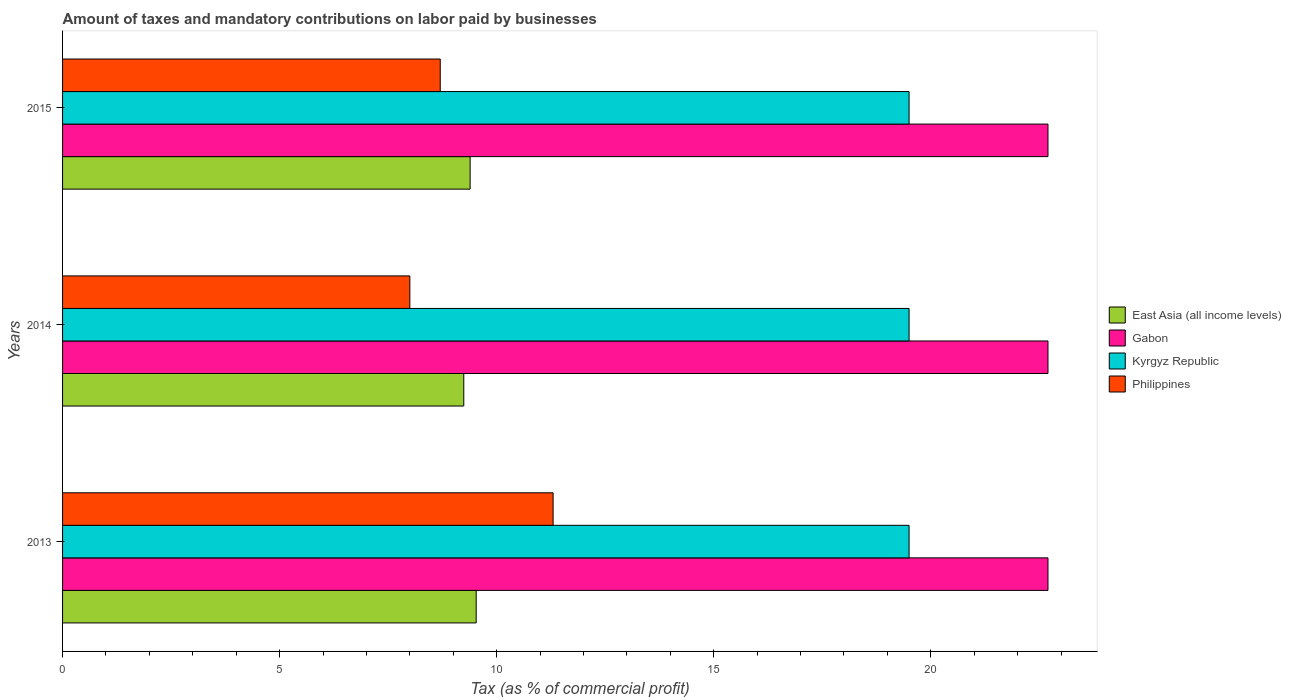How many different coloured bars are there?
Provide a short and direct response. 4. Are the number of bars per tick equal to the number of legend labels?
Ensure brevity in your answer.  Yes. Are the number of bars on each tick of the Y-axis equal?
Offer a terse response. Yes. How many bars are there on the 2nd tick from the top?
Your answer should be compact. 4. How many bars are there on the 2nd tick from the bottom?
Give a very brief answer. 4. What is the label of the 1st group of bars from the top?
Ensure brevity in your answer.  2015. What is the percentage of taxes paid by businesses in Gabon in 2015?
Keep it short and to the point. 22.7. Across all years, what is the minimum percentage of taxes paid by businesses in East Asia (all income levels)?
Ensure brevity in your answer.  9.24. In which year was the percentage of taxes paid by businesses in Philippines minimum?
Your answer should be very brief. 2014. What is the total percentage of taxes paid by businesses in Gabon in the graph?
Your answer should be very brief. 68.1. What is the difference between the percentage of taxes paid by businesses in Gabon in 2014 and that in 2015?
Provide a succinct answer. 0. What is the difference between the percentage of taxes paid by businesses in Philippines in 2014 and the percentage of taxes paid by businesses in Kyrgyz Republic in 2013?
Provide a short and direct response. -11.5. What is the average percentage of taxes paid by businesses in East Asia (all income levels) per year?
Provide a short and direct response. 9.39. In the year 2013, what is the difference between the percentage of taxes paid by businesses in Gabon and percentage of taxes paid by businesses in Kyrgyz Republic?
Provide a short and direct response. 3.2. What is the ratio of the percentage of taxes paid by businesses in Gabon in 2013 to that in 2014?
Offer a very short reply. 1. Is the percentage of taxes paid by businesses in Gabon in 2013 less than that in 2014?
Keep it short and to the point. No. Is the difference between the percentage of taxes paid by businesses in Gabon in 2013 and 2014 greater than the difference between the percentage of taxes paid by businesses in Kyrgyz Republic in 2013 and 2014?
Keep it short and to the point. No. What is the difference between the highest and the second highest percentage of taxes paid by businesses in Philippines?
Provide a succinct answer. 2.6. What is the difference between the highest and the lowest percentage of taxes paid by businesses in Philippines?
Offer a terse response. 3.3. Is the sum of the percentage of taxes paid by businesses in East Asia (all income levels) in 2013 and 2014 greater than the maximum percentage of taxes paid by businesses in Gabon across all years?
Offer a very short reply. No. Is it the case that in every year, the sum of the percentage of taxes paid by businesses in Kyrgyz Republic and percentage of taxes paid by businesses in Gabon is greater than the sum of percentage of taxes paid by businesses in Philippines and percentage of taxes paid by businesses in East Asia (all income levels)?
Your response must be concise. Yes. What does the 2nd bar from the bottom in 2013 represents?
Make the answer very short. Gabon. Is it the case that in every year, the sum of the percentage of taxes paid by businesses in East Asia (all income levels) and percentage of taxes paid by businesses in Philippines is greater than the percentage of taxes paid by businesses in Kyrgyz Republic?
Provide a short and direct response. No. How many years are there in the graph?
Keep it short and to the point. 3. Are the values on the major ticks of X-axis written in scientific E-notation?
Offer a very short reply. No. How many legend labels are there?
Provide a short and direct response. 4. What is the title of the graph?
Provide a short and direct response. Amount of taxes and mandatory contributions on labor paid by businesses. What is the label or title of the X-axis?
Offer a very short reply. Tax (as % of commercial profit). What is the label or title of the Y-axis?
Give a very brief answer. Years. What is the Tax (as % of commercial profit) in East Asia (all income levels) in 2013?
Ensure brevity in your answer.  9.53. What is the Tax (as % of commercial profit) of Gabon in 2013?
Your response must be concise. 22.7. What is the Tax (as % of commercial profit) in East Asia (all income levels) in 2014?
Ensure brevity in your answer.  9.24. What is the Tax (as % of commercial profit) of Gabon in 2014?
Offer a terse response. 22.7. What is the Tax (as % of commercial profit) in Philippines in 2014?
Your response must be concise. 8. What is the Tax (as % of commercial profit) of East Asia (all income levels) in 2015?
Give a very brief answer. 9.39. What is the Tax (as % of commercial profit) in Gabon in 2015?
Offer a terse response. 22.7. What is the Tax (as % of commercial profit) of Kyrgyz Republic in 2015?
Give a very brief answer. 19.5. Across all years, what is the maximum Tax (as % of commercial profit) of East Asia (all income levels)?
Make the answer very short. 9.53. Across all years, what is the maximum Tax (as % of commercial profit) in Gabon?
Offer a terse response. 22.7. Across all years, what is the maximum Tax (as % of commercial profit) in Philippines?
Make the answer very short. 11.3. Across all years, what is the minimum Tax (as % of commercial profit) in East Asia (all income levels)?
Provide a short and direct response. 9.24. Across all years, what is the minimum Tax (as % of commercial profit) in Gabon?
Offer a very short reply. 22.7. Across all years, what is the minimum Tax (as % of commercial profit) of Philippines?
Your response must be concise. 8. What is the total Tax (as % of commercial profit) of East Asia (all income levels) in the graph?
Offer a very short reply. 28.16. What is the total Tax (as % of commercial profit) in Gabon in the graph?
Your response must be concise. 68.1. What is the total Tax (as % of commercial profit) of Kyrgyz Republic in the graph?
Provide a short and direct response. 58.5. What is the total Tax (as % of commercial profit) in Philippines in the graph?
Offer a terse response. 28. What is the difference between the Tax (as % of commercial profit) of East Asia (all income levels) in 2013 and that in 2014?
Give a very brief answer. 0.29. What is the difference between the Tax (as % of commercial profit) of Gabon in 2013 and that in 2014?
Provide a succinct answer. 0. What is the difference between the Tax (as % of commercial profit) in Kyrgyz Republic in 2013 and that in 2014?
Offer a very short reply. 0. What is the difference between the Tax (as % of commercial profit) in Philippines in 2013 and that in 2014?
Your response must be concise. 3.3. What is the difference between the Tax (as % of commercial profit) in East Asia (all income levels) in 2013 and that in 2015?
Keep it short and to the point. 0.14. What is the difference between the Tax (as % of commercial profit) of Gabon in 2013 and that in 2015?
Ensure brevity in your answer.  0. What is the difference between the Tax (as % of commercial profit) of Kyrgyz Republic in 2013 and that in 2015?
Make the answer very short. 0. What is the difference between the Tax (as % of commercial profit) of Philippines in 2013 and that in 2015?
Keep it short and to the point. 2.6. What is the difference between the Tax (as % of commercial profit) in East Asia (all income levels) in 2014 and that in 2015?
Ensure brevity in your answer.  -0.15. What is the difference between the Tax (as % of commercial profit) in Gabon in 2014 and that in 2015?
Offer a terse response. 0. What is the difference between the Tax (as % of commercial profit) in Kyrgyz Republic in 2014 and that in 2015?
Your answer should be compact. 0. What is the difference between the Tax (as % of commercial profit) in Philippines in 2014 and that in 2015?
Give a very brief answer. -0.7. What is the difference between the Tax (as % of commercial profit) of East Asia (all income levels) in 2013 and the Tax (as % of commercial profit) of Gabon in 2014?
Give a very brief answer. -13.17. What is the difference between the Tax (as % of commercial profit) of East Asia (all income levels) in 2013 and the Tax (as % of commercial profit) of Kyrgyz Republic in 2014?
Your answer should be very brief. -9.97. What is the difference between the Tax (as % of commercial profit) in East Asia (all income levels) in 2013 and the Tax (as % of commercial profit) in Philippines in 2014?
Your answer should be very brief. 1.53. What is the difference between the Tax (as % of commercial profit) in Gabon in 2013 and the Tax (as % of commercial profit) in Kyrgyz Republic in 2014?
Make the answer very short. 3.2. What is the difference between the Tax (as % of commercial profit) in Kyrgyz Republic in 2013 and the Tax (as % of commercial profit) in Philippines in 2014?
Provide a succinct answer. 11.5. What is the difference between the Tax (as % of commercial profit) in East Asia (all income levels) in 2013 and the Tax (as % of commercial profit) in Gabon in 2015?
Offer a very short reply. -13.17. What is the difference between the Tax (as % of commercial profit) of East Asia (all income levels) in 2013 and the Tax (as % of commercial profit) of Kyrgyz Republic in 2015?
Provide a succinct answer. -9.97. What is the difference between the Tax (as % of commercial profit) of East Asia (all income levels) in 2013 and the Tax (as % of commercial profit) of Philippines in 2015?
Ensure brevity in your answer.  0.83. What is the difference between the Tax (as % of commercial profit) in East Asia (all income levels) in 2014 and the Tax (as % of commercial profit) in Gabon in 2015?
Your answer should be compact. -13.46. What is the difference between the Tax (as % of commercial profit) in East Asia (all income levels) in 2014 and the Tax (as % of commercial profit) in Kyrgyz Republic in 2015?
Keep it short and to the point. -10.26. What is the difference between the Tax (as % of commercial profit) of East Asia (all income levels) in 2014 and the Tax (as % of commercial profit) of Philippines in 2015?
Offer a very short reply. 0.54. What is the difference between the Tax (as % of commercial profit) in Gabon in 2014 and the Tax (as % of commercial profit) in Kyrgyz Republic in 2015?
Offer a very short reply. 3.2. What is the difference between the Tax (as % of commercial profit) in Kyrgyz Republic in 2014 and the Tax (as % of commercial profit) in Philippines in 2015?
Your answer should be compact. 10.8. What is the average Tax (as % of commercial profit) of East Asia (all income levels) per year?
Offer a terse response. 9.39. What is the average Tax (as % of commercial profit) in Gabon per year?
Give a very brief answer. 22.7. What is the average Tax (as % of commercial profit) of Philippines per year?
Provide a short and direct response. 9.33. In the year 2013, what is the difference between the Tax (as % of commercial profit) of East Asia (all income levels) and Tax (as % of commercial profit) of Gabon?
Make the answer very short. -13.17. In the year 2013, what is the difference between the Tax (as % of commercial profit) of East Asia (all income levels) and Tax (as % of commercial profit) of Kyrgyz Republic?
Make the answer very short. -9.97. In the year 2013, what is the difference between the Tax (as % of commercial profit) in East Asia (all income levels) and Tax (as % of commercial profit) in Philippines?
Ensure brevity in your answer.  -1.77. In the year 2013, what is the difference between the Tax (as % of commercial profit) in Gabon and Tax (as % of commercial profit) in Kyrgyz Republic?
Give a very brief answer. 3.2. In the year 2013, what is the difference between the Tax (as % of commercial profit) in Gabon and Tax (as % of commercial profit) in Philippines?
Provide a succinct answer. 11.4. In the year 2013, what is the difference between the Tax (as % of commercial profit) in Kyrgyz Republic and Tax (as % of commercial profit) in Philippines?
Your response must be concise. 8.2. In the year 2014, what is the difference between the Tax (as % of commercial profit) in East Asia (all income levels) and Tax (as % of commercial profit) in Gabon?
Your response must be concise. -13.46. In the year 2014, what is the difference between the Tax (as % of commercial profit) in East Asia (all income levels) and Tax (as % of commercial profit) in Kyrgyz Republic?
Give a very brief answer. -10.26. In the year 2014, what is the difference between the Tax (as % of commercial profit) of East Asia (all income levels) and Tax (as % of commercial profit) of Philippines?
Your response must be concise. 1.24. In the year 2014, what is the difference between the Tax (as % of commercial profit) of Gabon and Tax (as % of commercial profit) of Kyrgyz Republic?
Provide a short and direct response. 3.2. In the year 2014, what is the difference between the Tax (as % of commercial profit) in Gabon and Tax (as % of commercial profit) in Philippines?
Provide a succinct answer. 14.7. In the year 2015, what is the difference between the Tax (as % of commercial profit) of East Asia (all income levels) and Tax (as % of commercial profit) of Gabon?
Offer a very short reply. -13.31. In the year 2015, what is the difference between the Tax (as % of commercial profit) of East Asia (all income levels) and Tax (as % of commercial profit) of Kyrgyz Republic?
Make the answer very short. -10.11. In the year 2015, what is the difference between the Tax (as % of commercial profit) of East Asia (all income levels) and Tax (as % of commercial profit) of Philippines?
Your answer should be very brief. 0.69. In the year 2015, what is the difference between the Tax (as % of commercial profit) of Gabon and Tax (as % of commercial profit) of Philippines?
Provide a succinct answer. 14. What is the ratio of the Tax (as % of commercial profit) of East Asia (all income levels) in 2013 to that in 2014?
Offer a very short reply. 1.03. What is the ratio of the Tax (as % of commercial profit) of Kyrgyz Republic in 2013 to that in 2014?
Provide a short and direct response. 1. What is the ratio of the Tax (as % of commercial profit) in Philippines in 2013 to that in 2014?
Ensure brevity in your answer.  1.41. What is the ratio of the Tax (as % of commercial profit) of East Asia (all income levels) in 2013 to that in 2015?
Provide a short and direct response. 1.01. What is the ratio of the Tax (as % of commercial profit) in Gabon in 2013 to that in 2015?
Your answer should be very brief. 1. What is the ratio of the Tax (as % of commercial profit) of Kyrgyz Republic in 2013 to that in 2015?
Provide a succinct answer. 1. What is the ratio of the Tax (as % of commercial profit) in Philippines in 2013 to that in 2015?
Your response must be concise. 1.3. What is the ratio of the Tax (as % of commercial profit) of East Asia (all income levels) in 2014 to that in 2015?
Your answer should be very brief. 0.98. What is the ratio of the Tax (as % of commercial profit) in Philippines in 2014 to that in 2015?
Offer a terse response. 0.92. What is the difference between the highest and the second highest Tax (as % of commercial profit) of East Asia (all income levels)?
Offer a very short reply. 0.14. What is the difference between the highest and the second highest Tax (as % of commercial profit) of Gabon?
Give a very brief answer. 0. What is the difference between the highest and the second highest Tax (as % of commercial profit) of Philippines?
Give a very brief answer. 2.6. What is the difference between the highest and the lowest Tax (as % of commercial profit) in East Asia (all income levels)?
Your response must be concise. 0.29. What is the difference between the highest and the lowest Tax (as % of commercial profit) of Gabon?
Your answer should be very brief. 0. What is the difference between the highest and the lowest Tax (as % of commercial profit) of Philippines?
Provide a short and direct response. 3.3. 